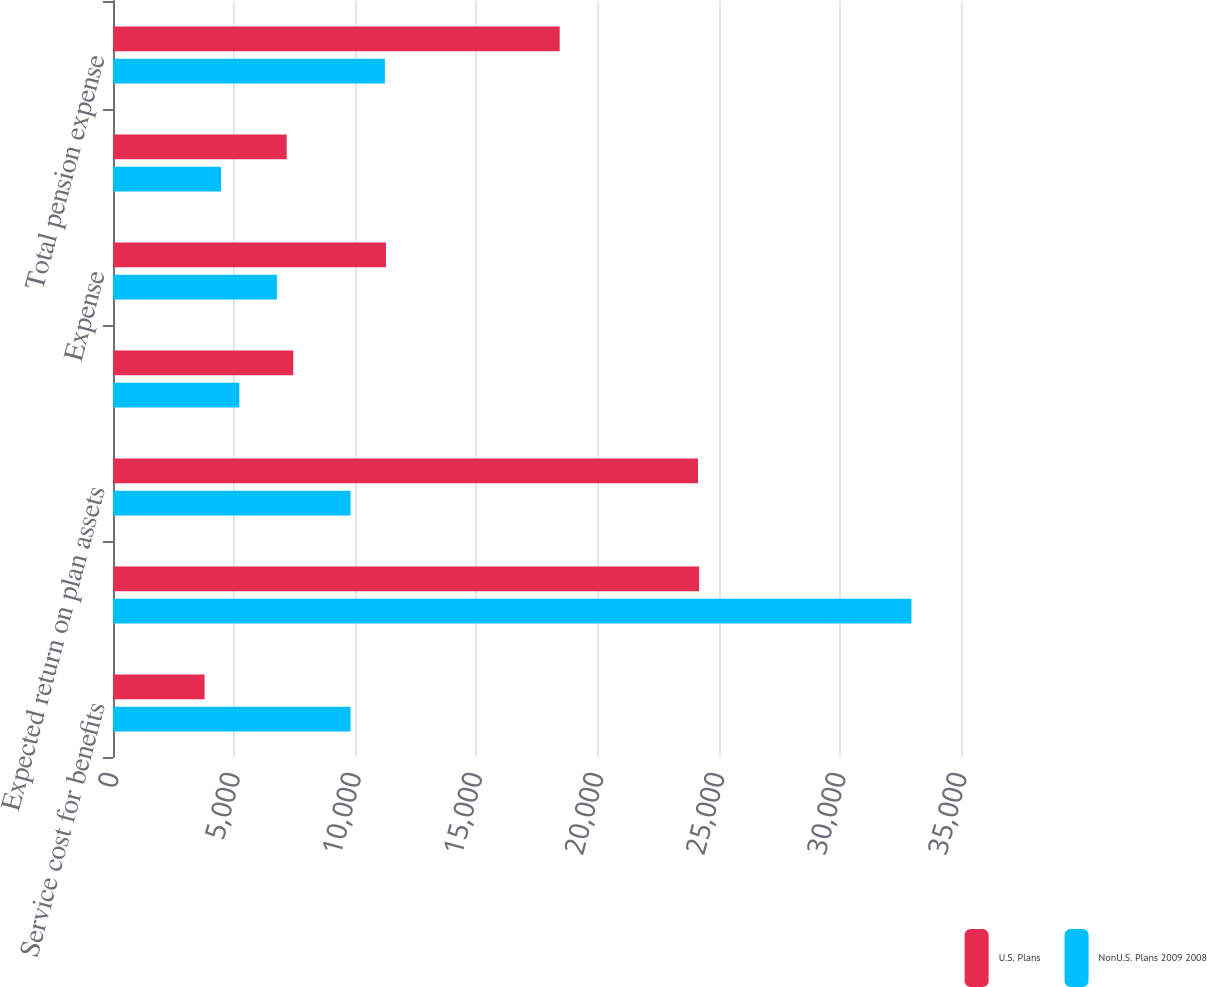Convert chart to OTSL. <chart><loc_0><loc_0><loc_500><loc_500><stacked_bar_chart><ecel><fcel>Service cost for benefits<fcel>Interest cost on projected<fcel>Expected return on plan assets<fcel>Net amortization and deferrals<fcel>Expense<fcel>Defined contribution and other<fcel>Total pension expense<nl><fcel>U.S. Plans<fcel>3781<fcel>24191<fcel>24146<fcel>7441<fcel>11267<fcel>7169<fcel>18436<nl><fcel>NonU.S. Plans 2009 2008<fcel>9804<fcel>32954<fcel>9804<fcel>5214<fcel>6763<fcel>4459<fcel>11222<nl></chart> 